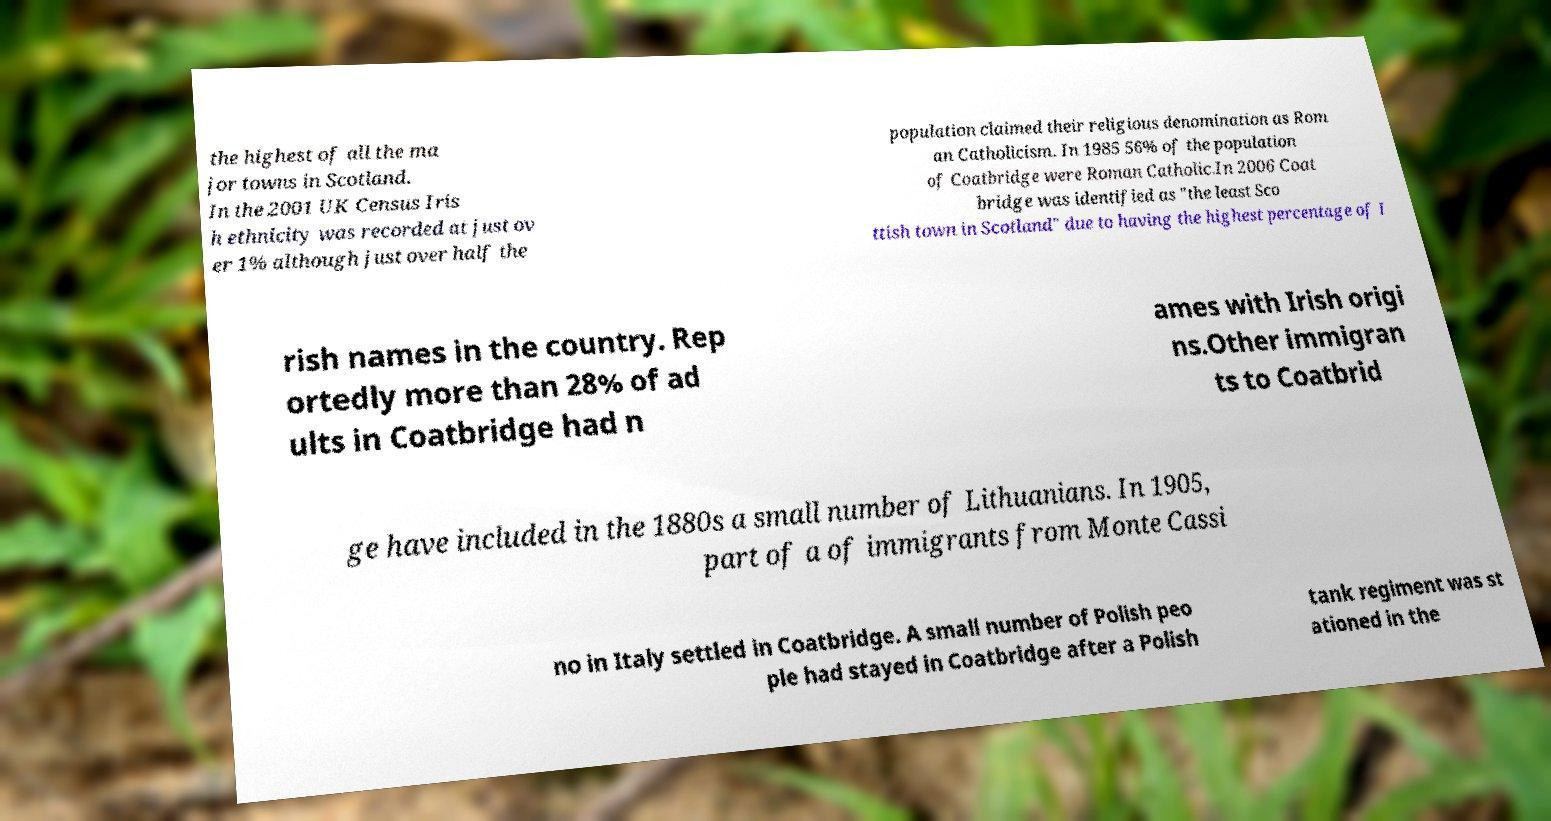What messages or text are displayed in this image? I need them in a readable, typed format. the highest of all the ma jor towns in Scotland. In the 2001 UK Census Iris h ethnicity was recorded at just ov er 1% although just over half the population claimed their religious denomination as Rom an Catholicism. In 1985 56% of the population of Coatbridge were Roman Catholic.In 2006 Coat bridge was identified as "the least Sco ttish town in Scotland" due to having the highest percentage of I rish names in the country. Rep ortedly more than 28% of ad ults in Coatbridge had n ames with Irish origi ns.Other immigran ts to Coatbrid ge have included in the 1880s a small number of Lithuanians. In 1905, part of a of immigrants from Monte Cassi no in Italy settled in Coatbridge. A small number of Polish peo ple had stayed in Coatbridge after a Polish tank regiment was st ationed in the 